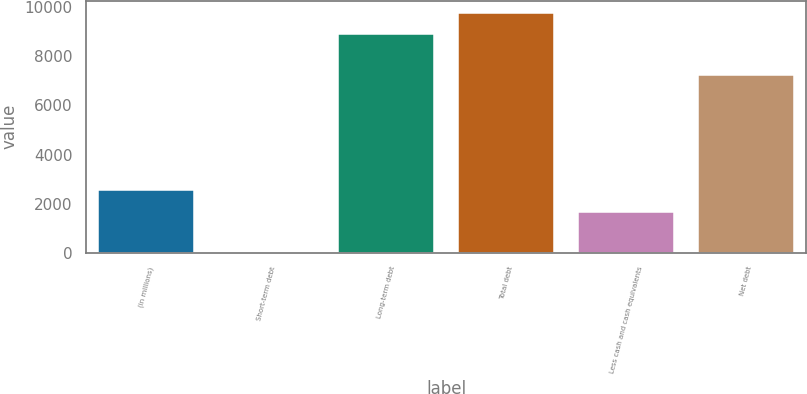Convert chart to OTSL. <chart><loc_0><loc_0><loc_500><loc_500><bar_chart><fcel>(in millions)<fcel>Short-term debt<fcel>Long-term debt<fcel>Total debt<fcel>Less cash and cash equivalents<fcel>Net debt<nl><fcel>2557.5<fcel>7<fcel>8895<fcel>9784.5<fcel>1668<fcel>7234<nl></chart> 